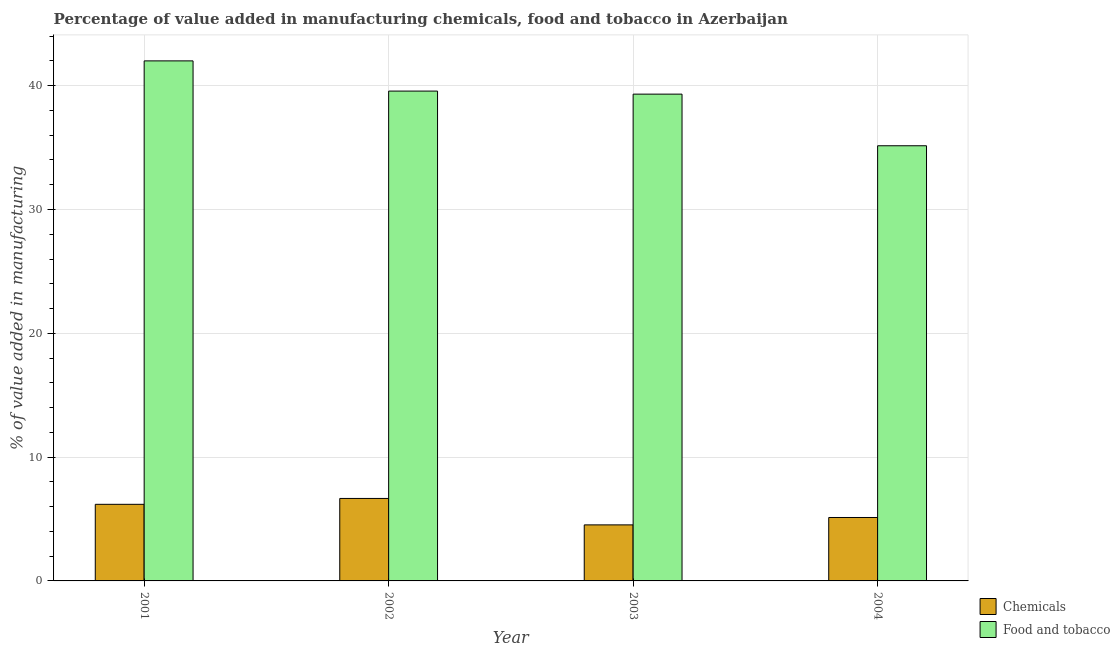How many groups of bars are there?
Ensure brevity in your answer.  4. Are the number of bars per tick equal to the number of legend labels?
Provide a succinct answer. Yes. Are the number of bars on each tick of the X-axis equal?
Keep it short and to the point. Yes. How many bars are there on the 3rd tick from the left?
Give a very brief answer. 2. How many bars are there on the 4th tick from the right?
Provide a short and direct response. 2. What is the label of the 3rd group of bars from the left?
Your answer should be compact. 2003. In how many cases, is the number of bars for a given year not equal to the number of legend labels?
Your response must be concise. 0. What is the value added by  manufacturing chemicals in 2004?
Offer a terse response. 5.12. Across all years, what is the maximum value added by manufacturing food and tobacco?
Offer a terse response. 42. Across all years, what is the minimum value added by manufacturing food and tobacco?
Your answer should be compact. 35.15. In which year was the value added by  manufacturing chemicals minimum?
Ensure brevity in your answer.  2003. What is the total value added by manufacturing food and tobacco in the graph?
Your answer should be very brief. 156.03. What is the difference between the value added by  manufacturing chemicals in 2001 and that in 2004?
Offer a very short reply. 1.06. What is the difference between the value added by  manufacturing chemicals in 2003 and the value added by manufacturing food and tobacco in 2004?
Ensure brevity in your answer.  -0.6. What is the average value added by  manufacturing chemicals per year?
Offer a very short reply. 5.62. What is the ratio of the value added by  manufacturing chemicals in 2001 to that in 2002?
Your answer should be very brief. 0.93. What is the difference between the highest and the second highest value added by  manufacturing chemicals?
Offer a very short reply. 0.47. What is the difference between the highest and the lowest value added by manufacturing food and tobacco?
Make the answer very short. 6.86. In how many years, is the value added by manufacturing food and tobacco greater than the average value added by manufacturing food and tobacco taken over all years?
Give a very brief answer. 3. Is the sum of the value added by  manufacturing chemicals in 2001 and 2002 greater than the maximum value added by manufacturing food and tobacco across all years?
Offer a very short reply. Yes. What does the 1st bar from the left in 2003 represents?
Provide a succinct answer. Chemicals. What does the 2nd bar from the right in 2003 represents?
Your response must be concise. Chemicals. What is the difference between two consecutive major ticks on the Y-axis?
Provide a short and direct response. 10. Where does the legend appear in the graph?
Provide a short and direct response. Bottom right. How are the legend labels stacked?
Provide a succinct answer. Vertical. What is the title of the graph?
Provide a short and direct response. Percentage of value added in manufacturing chemicals, food and tobacco in Azerbaijan. Does "Constant 2005 US$" appear as one of the legend labels in the graph?
Offer a very short reply. No. What is the label or title of the Y-axis?
Give a very brief answer. % of value added in manufacturing. What is the % of value added in manufacturing in Chemicals in 2001?
Your answer should be compact. 6.19. What is the % of value added in manufacturing of Food and tobacco in 2001?
Ensure brevity in your answer.  42. What is the % of value added in manufacturing in Chemicals in 2002?
Offer a very short reply. 6.66. What is the % of value added in manufacturing of Food and tobacco in 2002?
Provide a succinct answer. 39.56. What is the % of value added in manufacturing of Chemicals in 2003?
Provide a succinct answer. 4.53. What is the % of value added in manufacturing in Food and tobacco in 2003?
Keep it short and to the point. 39.32. What is the % of value added in manufacturing in Chemicals in 2004?
Make the answer very short. 5.12. What is the % of value added in manufacturing of Food and tobacco in 2004?
Provide a short and direct response. 35.15. Across all years, what is the maximum % of value added in manufacturing of Chemicals?
Ensure brevity in your answer.  6.66. Across all years, what is the maximum % of value added in manufacturing of Food and tobacco?
Ensure brevity in your answer.  42. Across all years, what is the minimum % of value added in manufacturing in Chemicals?
Your answer should be compact. 4.53. Across all years, what is the minimum % of value added in manufacturing of Food and tobacco?
Your answer should be compact. 35.15. What is the total % of value added in manufacturing in Chemicals in the graph?
Give a very brief answer. 22.5. What is the total % of value added in manufacturing of Food and tobacco in the graph?
Provide a succinct answer. 156.03. What is the difference between the % of value added in manufacturing in Chemicals in 2001 and that in 2002?
Keep it short and to the point. -0.47. What is the difference between the % of value added in manufacturing in Food and tobacco in 2001 and that in 2002?
Offer a very short reply. 2.44. What is the difference between the % of value added in manufacturing in Chemicals in 2001 and that in 2003?
Provide a succinct answer. 1.66. What is the difference between the % of value added in manufacturing of Food and tobacco in 2001 and that in 2003?
Provide a short and direct response. 2.69. What is the difference between the % of value added in manufacturing of Chemicals in 2001 and that in 2004?
Make the answer very short. 1.06. What is the difference between the % of value added in manufacturing of Food and tobacco in 2001 and that in 2004?
Provide a short and direct response. 6.86. What is the difference between the % of value added in manufacturing of Chemicals in 2002 and that in 2003?
Offer a terse response. 2.14. What is the difference between the % of value added in manufacturing in Food and tobacco in 2002 and that in 2003?
Provide a succinct answer. 0.24. What is the difference between the % of value added in manufacturing in Chemicals in 2002 and that in 2004?
Your answer should be compact. 1.54. What is the difference between the % of value added in manufacturing of Food and tobacco in 2002 and that in 2004?
Offer a very short reply. 4.41. What is the difference between the % of value added in manufacturing in Chemicals in 2003 and that in 2004?
Ensure brevity in your answer.  -0.6. What is the difference between the % of value added in manufacturing in Food and tobacco in 2003 and that in 2004?
Offer a very short reply. 4.17. What is the difference between the % of value added in manufacturing of Chemicals in 2001 and the % of value added in manufacturing of Food and tobacco in 2002?
Make the answer very short. -33.37. What is the difference between the % of value added in manufacturing in Chemicals in 2001 and the % of value added in manufacturing in Food and tobacco in 2003?
Your answer should be compact. -33.13. What is the difference between the % of value added in manufacturing in Chemicals in 2001 and the % of value added in manufacturing in Food and tobacco in 2004?
Your answer should be very brief. -28.96. What is the difference between the % of value added in manufacturing of Chemicals in 2002 and the % of value added in manufacturing of Food and tobacco in 2003?
Your answer should be compact. -32.65. What is the difference between the % of value added in manufacturing in Chemicals in 2002 and the % of value added in manufacturing in Food and tobacco in 2004?
Give a very brief answer. -28.49. What is the difference between the % of value added in manufacturing in Chemicals in 2003 and the % of value added in manufacturing in Food and tobacco in 2004?
Ensure brevity in your answer.  -30.62. What is the average % of value added in manufacturing in Chemicals per year?
Make the answer very short. 5.62. What is the average % of value added in manufacturing in Food and tobacco per year?
Provide a short and direct response. 39.01. In the year 2001, what is the difference between the % of value added in manufacturing of Chemicals and % of value added in manufacturing of Food and tobacco?
Your answer should be compact. -35.81. In the year 2002, what is the difference between the % of value added in manufacturing in Chemicals and % of value added in manufacturing in Food and tobacco?
Ensure brevity in your answer.  -32.9. In the year 2003, what is the difference between the % of value added in manufacturing in Chemicals and % of value added in manufacturing in Food and tobacco?
Your response must be concise. -34.79. In the year 2004, what is the difference between the % of value added in manufacturing of Chemicals and % of value added in manufacturing of Food and tobacco?
Ensure brevity in your answer.  -30.02. What is the ratio of the % of value added in manufacturing of Chemicals in 2001 to that in 2002?
Keep it short and to the point. 0.93. What is the ratio of the % of value added in manufacturing in Food and tobacco in 2001 to that in 2002?
Offer a terse response. 1.06. What is the ratio of the % of value added in manufacturing of Chemicals in 2001 to that in 2003?
Provide a succinct answer. 1.37. What is the ratio of the % of value added in manufacturing of Food and tobacco in 2001 to that in 2003?
Give a very brief answer. 1.07. What is the ratio of the % of value added in manufacturing in Chemicals in 2001 to that in 2004?
Offer a terse response. 1.21. What is the ratio of the % of value added in manufacturing in Food and tobacco in 2001 to that in 2004?
Keep it short and to the point. 1.2. What is the ratio of the % of value added in manufacturing of Chemicals in 2002 to that in 2003?
Keep it short and to the point. 1.47. What is the ratio of the % of value added in manufacturing in Food and tobacco in 2002 to that in 2003?
Offer a very short reply. 1.01. What is the ratio of the % of value added in manufacturing of Chemicals in 2002 to that in 2004?
Your answer should be compact. 1.3. What is the ratio of the % of value added in manufacturing in Food and tobacco in 2002 to that in 2004?
Provide a succinct answer. 1.13. What is the ratio of the % of value added in manufacturing of Chemicals in 2003 to that in 2004?
Offer a very short reply. 0.88. What is the ratio of the % of value added in manufacturing in Food and tobacco in 2003 to that in 2004?
Make the answer very short. 1.12. What is the difference between the highest and the second highest % of value added in manufacturing in Chemicals?
Keep it short and to the point. 0.47. What is the difference between the highest and the second highest % of value added in manufacturing in Food and tobacco?
Give a very brief answer. 2.44. What is the difference between the highest and the lowest % of value added in manufacturing in Chemicals?
Your answer should be very brief. 2.14. What is the difference between the highest and the lowest % of value added in manufacturing in Food and tobacco?
Offer a very short reply. 6.86. 